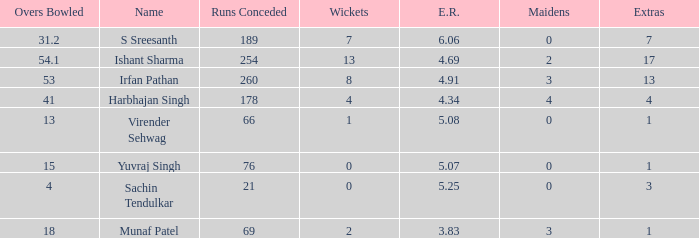Name the maaidens where overs bowled is 13 0.0. 